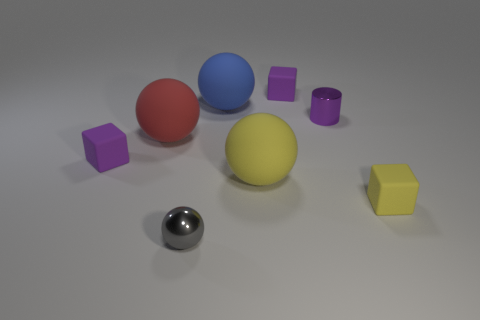What number of purple matte objects are there?
Offer a very short reply. 2. What number of cubes are either large yellow things or purple things?
Your answer should be very brief. 2. There is a large matte ball in front of the tiny purple cube to the left of the tiny ball; what number of shiny balls are to the left of it?
Your answer should be very brief. 1. There is a metallic ball that is the same size as the metallic cylinder; what is its color?
Make the answer very short. Gray. What number of other things are there of the same color as the shiny cylinder?
Ensure brevity in your answer.  2. Is the number of tiny purple shiny things behind the cylinder greater than the number of small spheres?
Ensure brevity in your answer.  No. Is the purple cylinder made of the same material as the yellow ball?
Make the answer very short. No. What number of things are rubber things that are in front of the large yellow thing or small yellow things?
Offer a terse response. 1. What number of other things are there of the same size as the blue ball?
Make the answer very short. 2. Are there the same number of big matte spheres that are to the right of the purple cylinder and yellow rubber spheres that are on the left side of the tiny metal sphere?
Offer a terse response. Yes. 